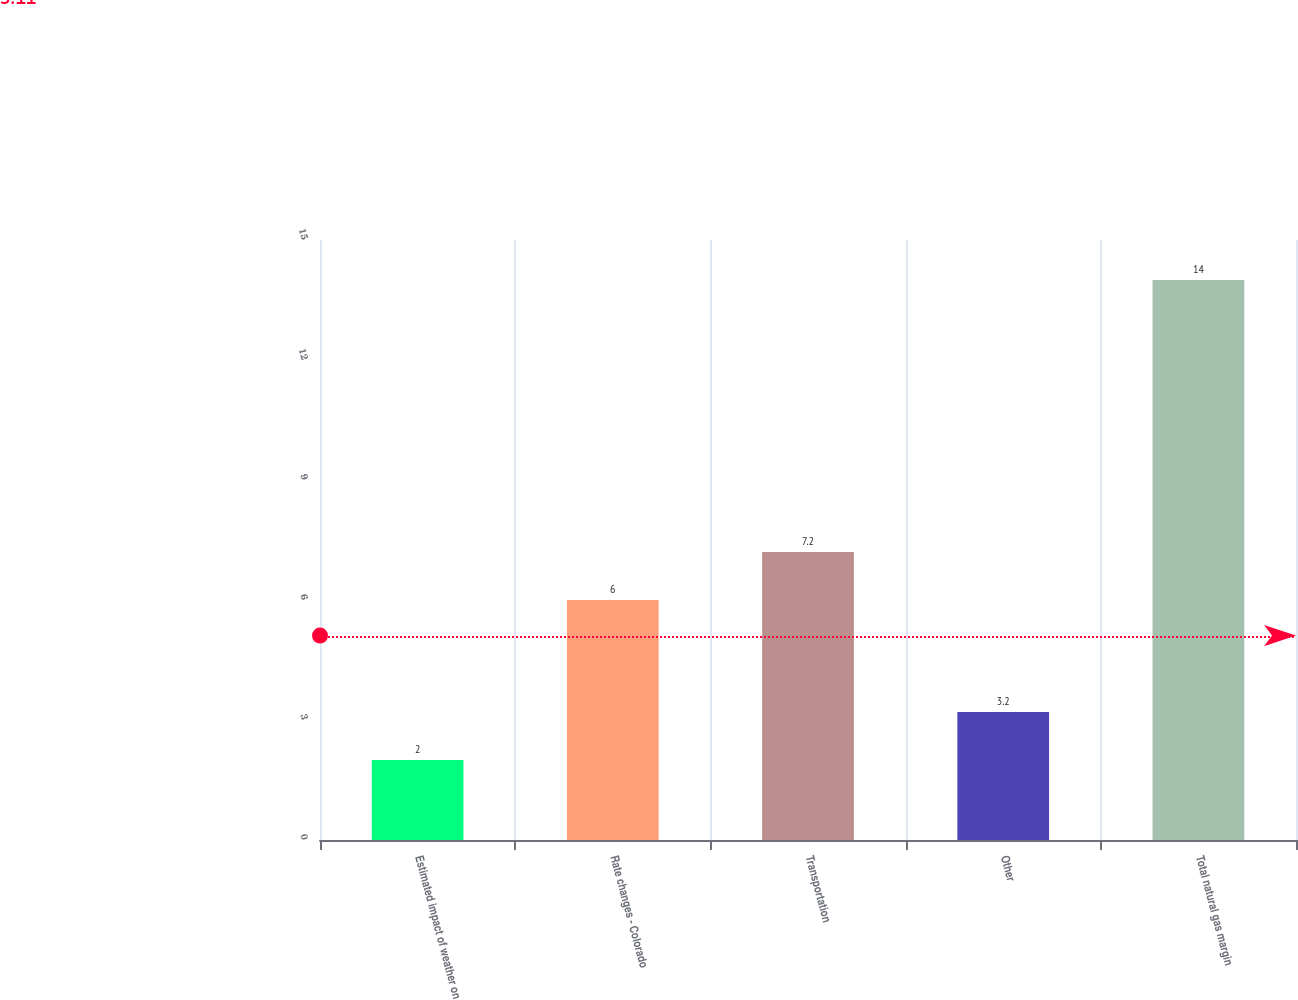Convert chart. <chart><loc_0><loc_0><loc_500><loc_500><bar_chart><fcel>Estimated impact of weather on<fcel>Rate changes - Colorado<fcel>Transportation<fcel>Other<fcel>Total natural gas margin<nl><fcel>2<fcel>6<fcel>7.2<fcel>3.2<fcel>14<nl></chart> 